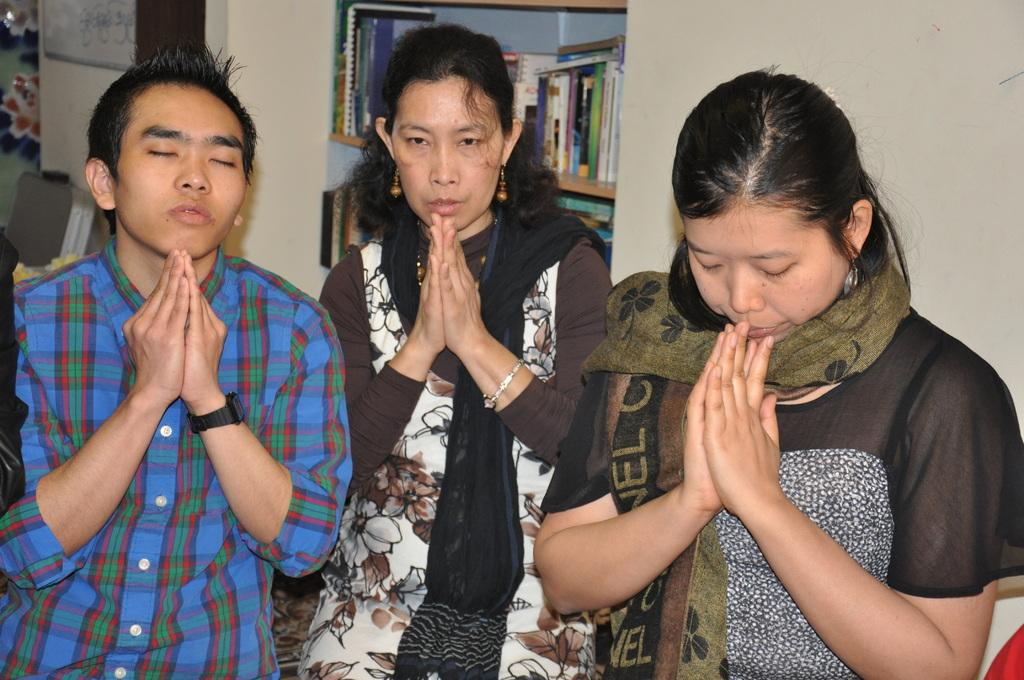How many people are in the image? There are two women in the image. What are the women doing in the image? The women are joining their hands. What can be seen in the background of the image? There is a wall and a shelf in the background of the image. What is on the shelf in the image? The shelf has books on it. What type of engine can be seen on the shelf in the image? There is no engine present on the shelf in the image; it has books on it. Is the woman's brother visible in the image? There is no information about a brother in the image, so it cannot be determined if he is present. 